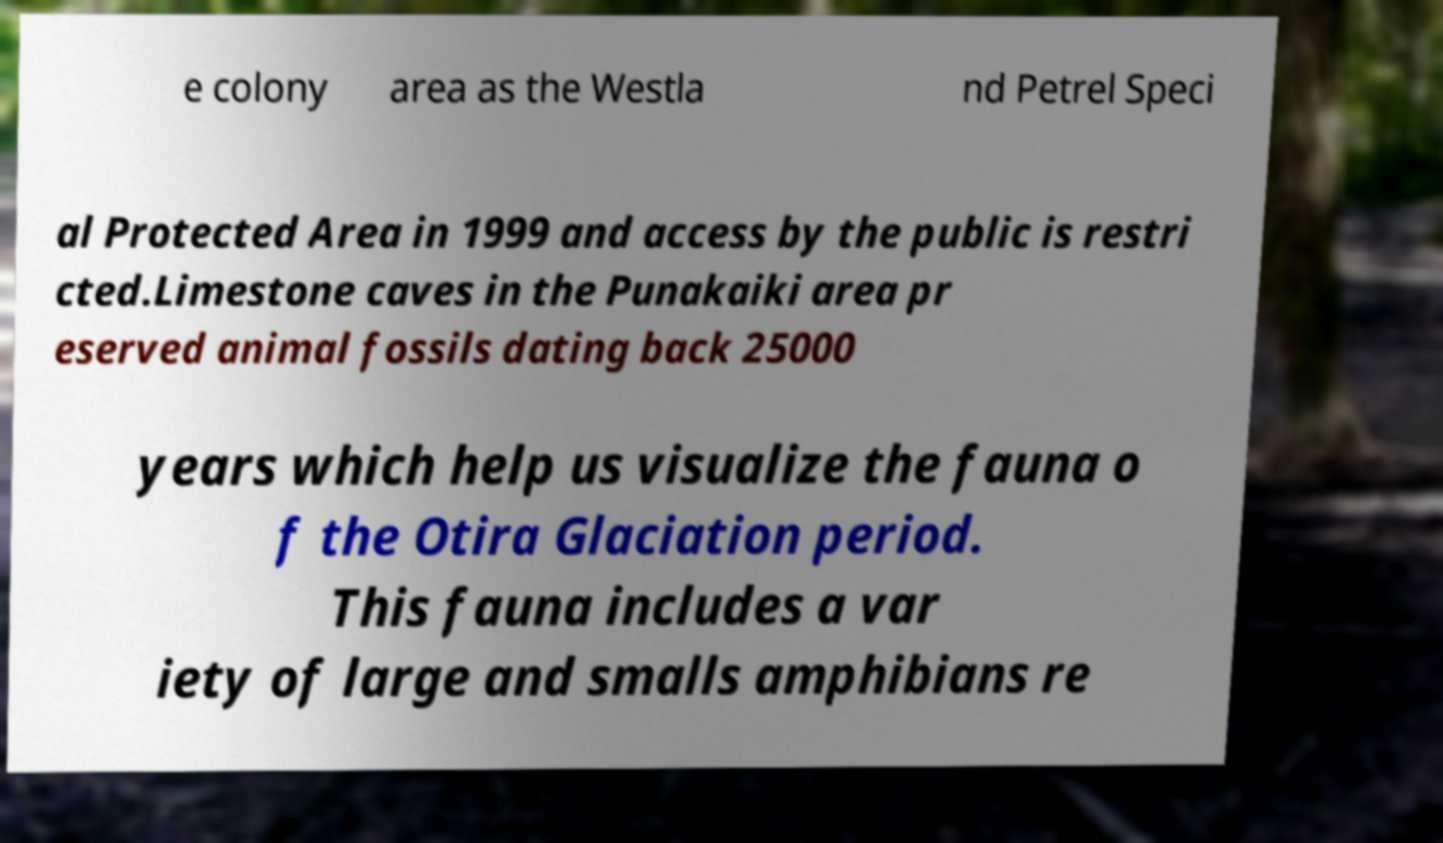Please identify and transcribe the text found in this image. e colony area as the Westla nd Petrel Speci al Protected Area in 1999 and access by the public is restri cted.Limestone caves in the Punakaiki area pr eserved animal fossils dating back 25000 years which help us visualize the fauna o f the Otira Glaciation period. This fauna includes a var iety of large and smalls amphibians re 